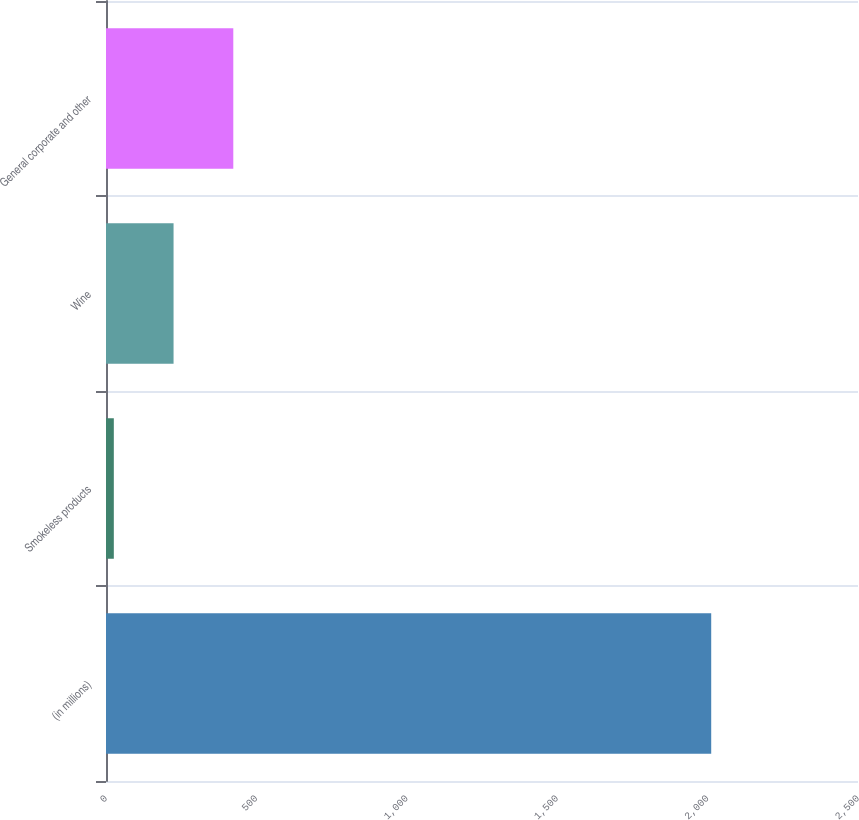Convert chart. <chart><loc_0><loc_0><loc_500><loc_500><bar_chart><fcel>(in millions)<fcel>Smokeless products<fcel>Wine<fcel>General corporate and other<nl><fcel>2012<fcel>26<fcel>224.6<fcel>423.2<nl></chart> 